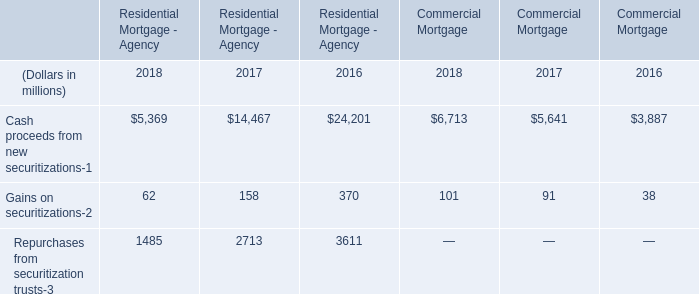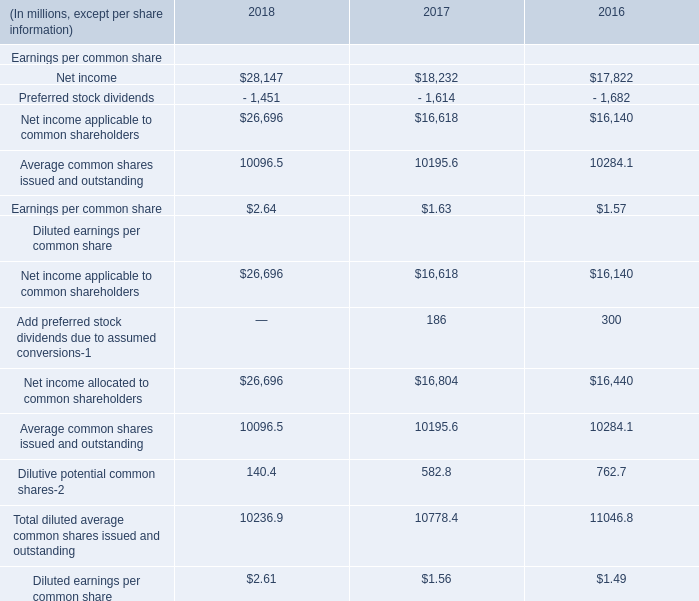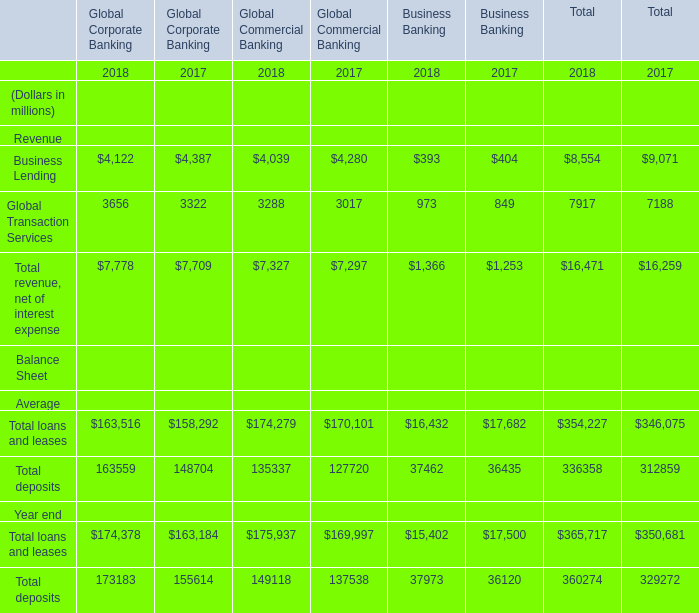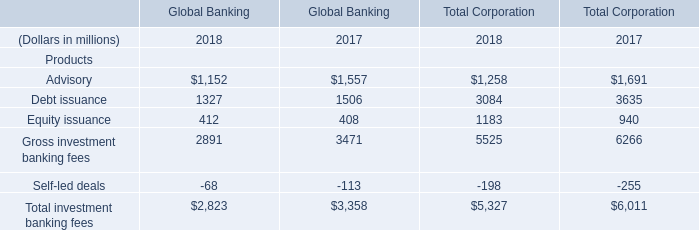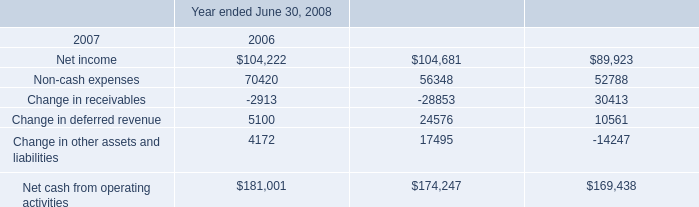What's the average of Advisory of Global Banking and Advisory of Total Corporation in 2018? (in dollars in millions) 
Computations: ((1152 + 1258) / 2)
Answer: 1205.0. 